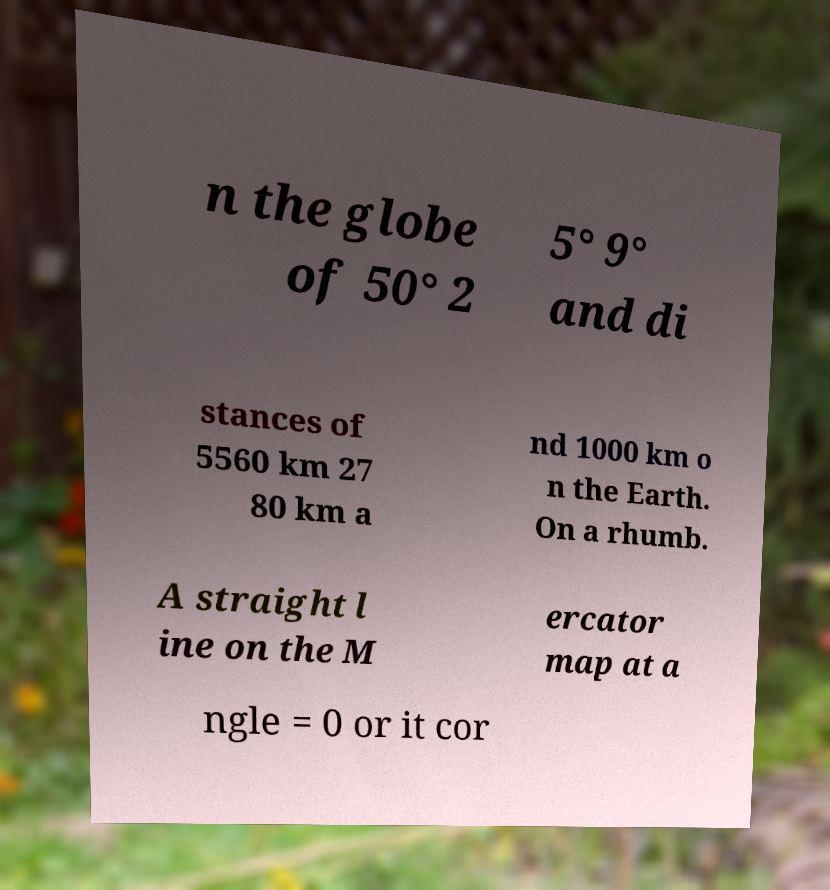For documentation purposes, I need the text within this image transcribed. Could you provide that? n the globe of 50° 2 5° 9° and di stances of 5560 km 27 80 km a nd 1000 km o n the Earth. On a rhumb. A straight l ine on the M ercator map at a ngle = 0 or it cor 